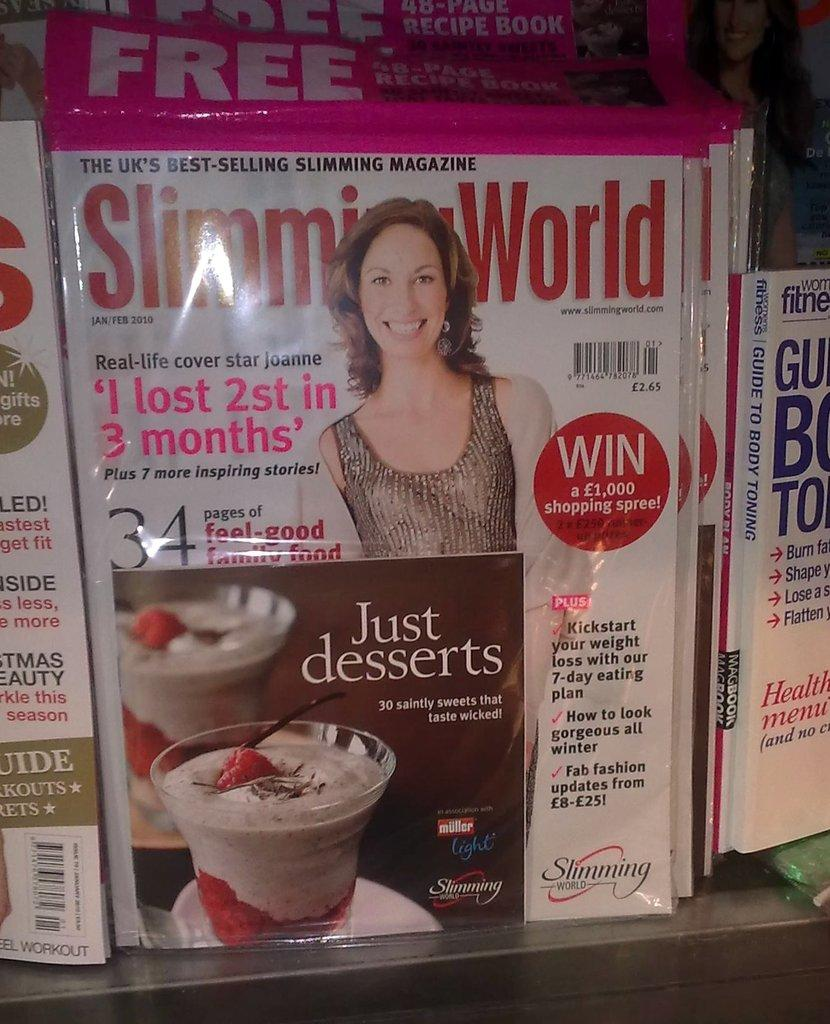<image>
Provide a brief description of the given image. With this magazine you can win a £1000 shopping spree. 